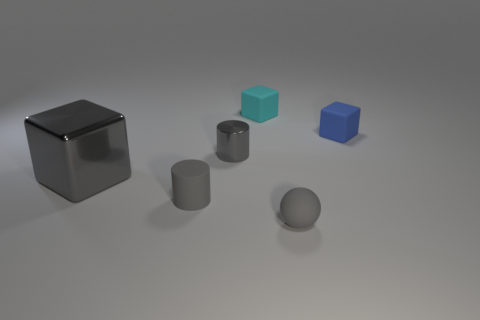Add 4 small cyan metallic balls. How many objects exist? 10 Subtract all balls. How many objects are left? 5 Add 4 cylinders. How many cylinders are left? 6 Add 5 tiny cyan shiny cylinders. How many tiny cyan shiny cylinders exist? 5 Subtract 0 green spheres. How many objects are left? 6 Subtract all gray shiny cylinders. Subtract all large balls. How many objects are left? 5 